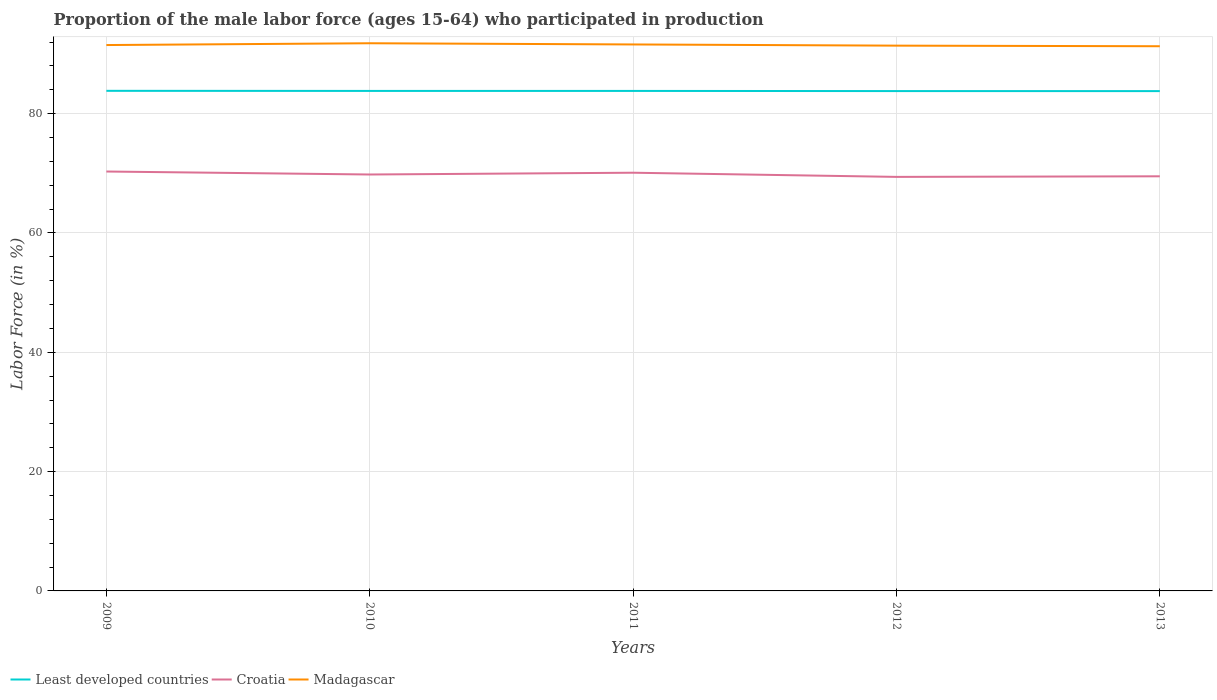Does the line corresponding to Least developed countries intersect with the line corresponding to Croatia?
Your answer should be very brief. No. Is the number of lines equal to the number of legend labels?
Ensure brevity in your answer.  Yes. Across all years, what is the maximum proportion of the male labor force who participated in production in Least developed countries?
Keep it short and to the point. 83.78. What is the total proportion of the male labor force who participated in production in Least developed countries in the graph?
Keep it short and to the point. 0. What is the difference between the highest and the second highest proportion of the male labor force who participated in production in Least developed countries?
Ensure brevity in your answer.  0.05. How many years are there in the graph?
Your answer should be compact. 5. Does the graph contain any zero values?
Make the answer very short. No. How many legend labels are there?
Give a very brief answer. 3. What is the title of the graph?
Give a very brief answer. Proportion of the male labor force (ages 15-64) who participated in production. What is the label or title of the X-axis?
Your answer should be compact. Years. What is the Labor Force (in %) of Least developed countries in 2009?
Provide a succinct answer. 83.83. What is the Labor Force (in %) in Croatia in 2009?
Offer a very short reply. 70.3. What is the Labor Force (in %) of Madagascar in 2009?
Keep it short and to the point. 91.5. What is the Labor Force (in %) in Least developed countries in 2010?
Ensure brevity in your answer.  83.81. What is the Labor Force (in %) of Croatia in 2010?
Offer a terse response. 69.8. What is the Labor Force (in %) of Madagascar in 2010?
Ensure brevity in your answer.  91.8. What is the Labor Force (in %) in Least developed countries in 2011?
Ensure brevity in your answer.  83.81. What is the Labor Force (in %) of Croatia in 2011?
Offer a very short reply. 70.1. What is the Labor Force (in %) of Madagascar in 2011?
Ensure brevity in your answer.  91.6. What is the Labor Force (in %) of Least developed countries in 2012?
Offer a terse response. 83.78. What is the Labor Force (in %) in Croatia in 2012?
Give a very brief answer. 69.4. What is the Labor Force (in %) in Madagascar in 2012?
Your answer should be very brief. 91.4. What is the Labor Force (in %) in Least developed countries in 2013?
Provide a short and direct response. 83.78. What is the Labor Force (in %) of Croatia in 2013?
Offer a very short reply. 69.5. What is the Labor Force (in %) of Madagascar in 2013?
Keep it short and to the point. 91.3. Across all years, what is the maximum Labor Force (in %) in Least developed countries?
Ensure brevity in your answer.  83.83. Across all years, what is the maximum Labor Force (in %) in Croatia?
Your response must be concise. 70.3. Across all years, what is the maximum Labor Force (in %) in Madagascar?
Your answer should be very brief. 91.8. Across all years, what is the minimum Labor Force (in %) in Least developed countries?
Keep it short and to the point. 83.78. Across all years, what is the minimum Labor Force (in %) in Croatia?
Keep it short and to the point. 69.4. Across all years, what is the minimum Labor Force (in %) of Madagascar?
Ensure brevity in your answer.  91.3. What is the total Labor Force (in %) in Least developed countries in the graph?
Your answer should be compact. 419.01. What is the total Labor Force (in %) in Croatia in the graph?
Provide a short and direct response. 349.1. What is the total Labor Force (in %) of Madagascar in the graph?
Offer a very short reply. 457.6. What is the difference between the Labor Force (in %) of Least developed countries in 2009 and that in 2010?
Your answer should be compact. 0.02. What is the difference between the Labor Force (in %) in Croatia in 2009 and that in 2010?
Give a very brief answer. 0.5. What is the difference between the Labor Force (in %) of Madagascar in 2009 and that in 2010?
Your answer should be compact. -0.3. What is the difference between the Labor Force (in %) in Least developed countries in 2009 and that in 2011?
Offer a terse response. 0.02. What is the difference between the Labor Force (in %) in Madagascar in 2009 and that in 2011?
Give a very brief answer. -0.1. What is the difference between the Labor Force (in %) in Least developed countries in 2009 and that in 2012?
Provide a short and direct response. 0.04. What is the difference between the Labor Force (in %) of Madagascar in 2009 and that in 2012?
Keep it short and to the point. 0.1. What is the difference between the Labor Force (in %) in Least developed countries in 2009 and that in 2013?
Your response must be concise. 0.05. What is the difference between the Labor Force (in %) in Croatia in 2009 and that in 2013?
Your answer should be very brief. 0.8. What is the difference between the Labor Force (in %) of Croatia in 2010 and that in 2011?
Your response must be concise. -0.3. What is the difference between the Labor Force (in %) in Least developed countries in 2010 and that in 2012?
Your response must be concise. 0.03. What is the difference between the Labor Force (in %) in Croatia in 2010 and that in 2012?
Your answer should be very brief. 0.4. What is the difference between the Labor Force (in %) in Least developed countries in 2010 and that in 2013?
Your answer should be very brief. 0.03. What is the difference between the Labor Force (in %) in Madagascar in 2010 and that in 2013?
Your response must be concise. 0.5. What is the difference between the Labor Force (in %) in Least developed countries in 2011 and that in 2012?
Ensure brevity in your answer.  0.03. What is the difference between the Labor Force (in %) in Croatia in 2011 and that in 2012?
Offer a very short reply. 0.7. What is the difference between the Labor Force (in %) of Madagascar in 2011 and that in 2012?
Your answer should be compact. 0.2. What is the difference between the Labor Force (in %) in Least developed countries in 2011 and that in 2013?
Offer a very short reply. 0.03. What is the difference between the Labor Force (in %) in Madagascar in 2011 and that in 2013?
Keep it short and to the point. 0.3. What is the difference between the Labor Force (in %) in Least developed countries in 2012 and that in 2013?
Offer a terse response. 0. What is the difference between the Labor Force (in %) in Least developed countries in 2009 and the Labor Force (in %) in Croatia in 2010?
Provide a succinct answer. 14.03. What is the difference between the Labor Force (in %) of Least developed countries in 2009 and the Labor Force (in %) of Madagascar in 2010?
Make the answer very short. -7.97. What is the difference between the Labor Force (in %) in Croatia in 2009 and the Labor Force (in %) in Madagascar in 2010?
Make the answer very short. -21.5. What is the difference between the Labor Force (in %) of Least developed countries in 2009 and the Labor Force (in %) of Croatia in 2011?
Your answer should be very brief. 13.73. What is the difference between the Labor Force (in %) of Least developed countries in 2009 and the Labor Force (in %) of Madagascar in 2011?
Your response must be concise. -7.77. What is the difference between the Labor Force (in %) of Croatia in 2009 and the Labor Force (in %) of Madagascar in 2011?
Your answer should be very brief. -21.3. What is the difference between the Labor Force (in %) of Least developed countries in 2009 and the Labor Force (in %) of Croatia in 2012?
Provide a short and direct response. 14.43. What is the difference between the Labor Force (in %) in Least developed countries in 2009 and the Labor Force (in %) in Madagascar in 2012?
Your answer should be compact. -7.57. What is the difference between the Labor Force (in %) of Croatia in 2009 and the Labor Force (in %) of Madagascar in 2012?
Give a very brief answer. -21.1. What is the difference between the Labor Force (in %) in Least developed countries in 2009 and the Labor Force (in %) in Croatia in 2013?
Keep it short and to the point. 14.33. What is the difference between the Labor Force (in %) of Least developed countries in 2009 and the Labor Force (in %) of Madagascar in 2013?
Your answer should be very brief. -7.47. What is the difference between the Labor Force (in %) of Croatia in 2009 and the Labor Force (in %) of Madagascar in 2013?
Ensure brevity in your answer.  -21. What is the difference between the Labor Force (in %) of Least developed countries in 2010 and the Labor Force (in %) of Croatia in 2011?
Make the answer very short. 13.71. What is the difference between the Labor Force (in %) of Least developed countries in 2010 and the Labor Force (in %) of Madagascar in 2011?
Give a very brief answer. -7.79. What is the difference between the Labor Force (in %) in Croatia in 2010 and the Labor Force (in %) in Madagascar in 2011?
Keep it short and to the point. -21.8. What is the difference between the Labor Force (in %) of Least developed countries in 2010 and the Labor Force (in %) of Croatia in 2012?
Your answer should be compact. 14.41. What is the difference between the Labor Force (in %) of Least developed countries in 2010 and the Labor Force (in %) of Madagascar in 2012?
Your answer should be very brief. -7.59. What is the difference between the Labor Force (in %) in Croatia in 2010 and the Labor Force (in %) in Madagascar in 2012?
Your answer should be compact. -21.6. What is the difference between the Labor Force (in %) in Least developed countries in 2010 and the Labor Force (in %) in Croatia in 2013?
Offer a terse response. 14.31. What is the difference between the Labor Force (in %) in Least developed countries in 2010 and the Labor Force (in %) in Madagascar in 2013?
Your answer should be very brief. -7.49. What is the difference between the Labor Force (in %) of Croatia in 2010 and the Labor Force (in %) of Madagascar in 2013?
Provide a succinct answer. -21.5. What is the difference between the Labor Force (in %) of Least developed countries in 2011 and the Labor Force (in %) of Croatia in 2012?
Your answer should be compact. 14.41. What is the difference between the Labor Force (in %) of Least developed countries in 2011 and the Labor Force (in %) of Madagascar in 2012?
Give a very brief answer. -7.59. What is the difference between the Labor Force (in %) of Croatia in 2011 and the Labor Force (in %) of Madagascar in 2012?
Offer a terse response. -21.3. What is the difference between the Labor Force (in %) of Least developed countries in 2011 and the Labor Force (in %) of Croatia in 2013?
Give a very brief answer. 14.31. What is the difference between the Labor Force (in %) in Least developed countries in 2011 and the Labor Force (in %) in Madagascar in 2013?
Give a very brief answer. -7.49. What is the difference between the Labor Force (in %) in Croatia in 2011 and the Labor Force (in %) in Madagascar in 2013?
Make the answer very short. -21.2. What is the difference between the Labor Force (in %) of Least developed countries in 2012 and the Labor Force (in %) of Croatia in 2013?
Ensure brevity in your answer.  14.28. What is the difference between the Labor Force (in %) in Least developed countries in 2012 and the Labor Force (in %) in Madagascar in 2013?
Offer a terse response. -7.52. What is the difference between the Labor Force (in %) of Croatia in 2012 and the Labor Force (in %) of Madagascar in 2013?
Ensure brevity in your answer.  -21.9. What is the average Labor Force (in %) in Least developed countries per year?
Provide a succinct answer. 83.8. What is the average Labor Force (in %) of Croatia per year?
Ensure brevity in your answer.  69.82. What is the average Labor Force (in %) in Madagascar per year?
Your answer should be compact. 91.52. In the year 2009, what is the difference between the Labor Force (in %) of Least developed countries and Labor Force (in %) of Croatia?
Provide a short and direct response. 13.53. In the year 2009, what is the difference between the Labor Force (in %) in Least developed countries and Labor Force (in %) in Madagascar?
Your answer should be very brief. -7.67. In the year 2009, what is the difference between the Labor Force (in %) of Croatia and Labor Force (in %) of Madagascar?
Offer a very short reply. -21.2. In the year 2010, what is the difference between the Labor Force (in %) of Least developed countries and Labor Force (in %) of Croatia?
Your answer should be very brief. 14.01. In the year 2010, what is the difference between the Labor Force (in %) in Least developed countries and Labor Force (in %) in Madagascar?
Offer a very short reply. -7.99. In the year 2010, what is the difference between the Labor Force (in %) of Croatia and Labor Force (in %) of Madagascar?
Make the answer very short. -22. In the year 2011, what is the difference between the Labor Force (in %) in Least developed countries and Labor Force (in %) in Croatia?
Ensure brevity in your answer.  13.71. In the year 2011, what is the difference between the Labor Force (in %) in Least developed countries and Labor Force (in %) in Madagascar?
Ensure brevity in your answer.  -7.79. In the year 2011, what is the difference between the Labor Force (in %) of Croatia and Labor Force (in %) of Madagascar?
Your answer should be very brief. -21.5. In the year 2012, what is the difference between the Labor Force (in %) of Least developed countries and Labor Force (in %) of Croatia?
Provide a succinct answer. 14.38. In the year 2012, what is the difference between the Labor Force (in %) of Least developed countries and Labor Force (in %) of Madagascar?
Your response must be concise. -7.62. In the year 2012, what is the difference between the Labor Force (in %) in Croatia and Labor Force (in %) in Madagascar?
Offer a very short reply. -22. In the year 2013, what is the difference between the Labor Force (in %) of Least developed countries and Labor Force (in %) of Croatia?
Provide a short and direct response. 14.28. In the year 2013, what is the difference between the Labor Force (in %) in Least developed countries and Labor Force (in %) in Madagascar?
Provide a short and direct response. -7.52. In the year 2013, what is the difference between the Labor Force (in %) of Croatia and Labor Force (in %) of Madagascar?
Provide a short and direct response. -21.8. What is the ratio of the Labor Force (in %) of Croatia in 2009 to that in 2010?
Keep it short and to the point. 1.01. What is the ratio of the Labor Force (in %) of Madagascar in 2009 to that in 2010?
Make the answer very short. 1. What is the ratio of the Labor Force (in %) of Least developed countries in 2009 to that in 2011?
Provide a short and direct response. 1. What is the ratio of the Labor Force (in %) in Least developed countries in 2009 to that in 2012?
Your response must be concise. 1. What is the ratio of the Labor Force (in %) of Croatia in 2009 to that in 2012?
Offer a very short reply. 1.01. What is the ratio of the Labor Force (in %) of Croatia in 2009 to that in 2013?
Keep it short and to the point. 1.01. What is the ratio of the Labor Force (in %) in Madagascar in 2009 to that in 2013?
Keep it short and to the point. 1. What is the ratio of the Labor Force (in %) of Least developed countries in 2010 to that in 2011?
Ensure brevity in your answer.  1. What is the ratio of the Labor Force (in %) in Croatia in 2010 to that in 2011?
Keep it short and to the point. 1. What is the ratio of the Labor Force (in %) in Madagascar in 2010 to that in 2011?
Provide a succinct answer. 1. What is the ratio of the Labor Force (in %) in Croatia in 2010 to that in 2012?
Your answer should be very brief. 1.01. What is the ratio of the Labor Force (in %) of Madagascar in 2010 to that in 2012?
Provide a short and direct response. 1. What is the ratio of the Labor Force (in %) in Least developed countries in 2010 to that in 2013?
Provide a short and direct response. 1. What is the ratio of the Labor Force (in %) of Madagascar in 2010 to that in 2013?
Provide a short and direct response. 1.01. What is the ratio of the Labor Force (in %) of Least developed countries in 2011 to that in 2012?
Provide a short and direct response. 1. What is the ratio of the Labor Force (in %) in Croatia in 2011 to that in 2013?
Provide a succinct answer. 1.01. What is the ratio of the Labor Force (in %) of Least developed countries in 2012 to that in 2013?
Your response must be concise. 1. What is the ratio of the Labor Force (in %) in Madagascar in 2012 to that in 2013?
Offer a terse response. 1. What is the difference between the highest and the second highest Labor Force (in %) in Least developed countries?
Ensure brevity in your answer.  0.02. What is the difference between the highest and the second highest Labor Force (in %) in Madagascar?
Your response must be concise. 0.2. What is the difference between the highest and the lowest Labor Force (in %) of Least developed countries?
Offer a terse response. 0.05. 